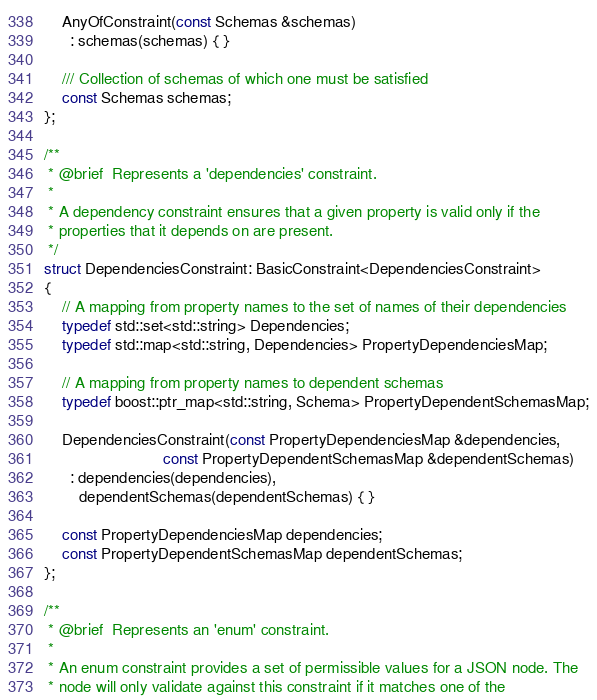<code> <loc_0><loc_0><loc_500><loc_500><_C++_>    AnyOfConstraint(const Schemas &schemas)
      : schemas(schemas) { }

    /// Collection of schemas of which one must be satisfied
    const Schemas schemas;
};

/**
 * @brief  Represents a 'dependencies' constraint.
 *
 * A dependency constraint ensures that a given property is valid only if the
 * properties that it depends on are present.
 */
struct DependenciesConstraint: BasicConstraint<DependenciesConstraint>
{
    // A mapping from property names to the set of names of their dependencies
    typedef std::set<std::string> Dependencies;
    typedef std::map<std::string, Dependencies> PropertyDependenciesMap;

    // A mapping from property names to dependent schemas
    typedef boost::ptr_map<std::string, Schema> PropertyDependentSchemasMap;

    DependenciesConstraint(const PropertyDependenciesMap &dependencies,
                           const PropertyDependentSchemasMap &dependentSchemas)
      : dependencies(dependencies),
        dependentSchemas(dependentSchemas) { }

    const PropertyDependenciesMap dependencies;
    const PropertyDependentSchemasMap dependentSchemas;
};

/**
 * @brief  Represents an 'enum' constraint.
 *
 * An enum constraint provides a set of permissible values for a JSON node. The
 * node will only validate against this constraint if it matches one of the</code> 